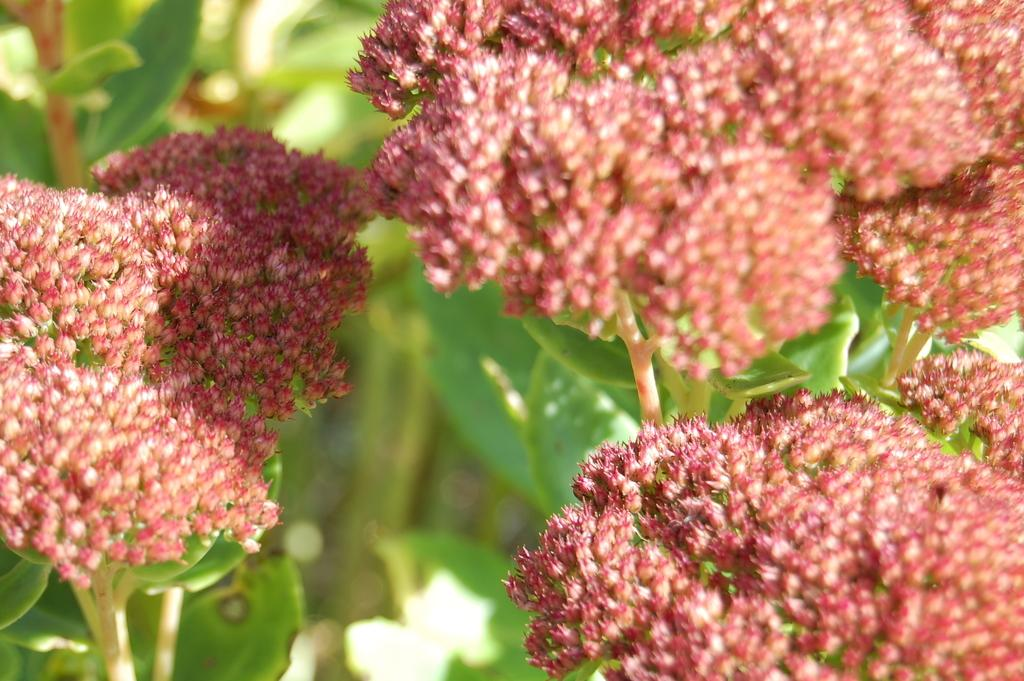What type of living organisms can be seen in the image? There are flowers in the image. What colors are the flowers in the image? The flowers are orange, red, and cream in color. What color are the plants in the image? The plants in the image are green in color. How would you describe the background of the image? The background of the image is blurry. What type of lettuce is growing in the image? There is no lettuce present in the image; it features flowers and plants. How far can the flowers stretch in the image? Flowers do not stretch; they grow and bloom. In the image, the flowers are stationary and not depicted as stretching. 